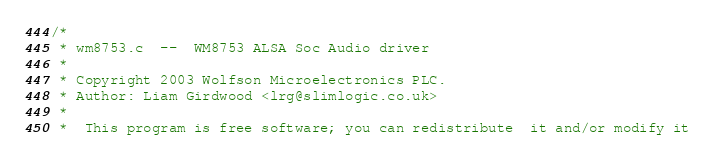Convert code to text. <code><loc_0><loc_0><loc_500><loc_500><_C_>/*
 * wm8753.c  --  WM8753 ALSA Soc Audio driver
 *
 * Copyright 2003 Wolfson Microelectronics PLC.
 * Author: Liam Girdwood <lrg@slimlogic.co.uk>
 *
 *  This program is free software; you can redistribute  it and/or modify it</code> 